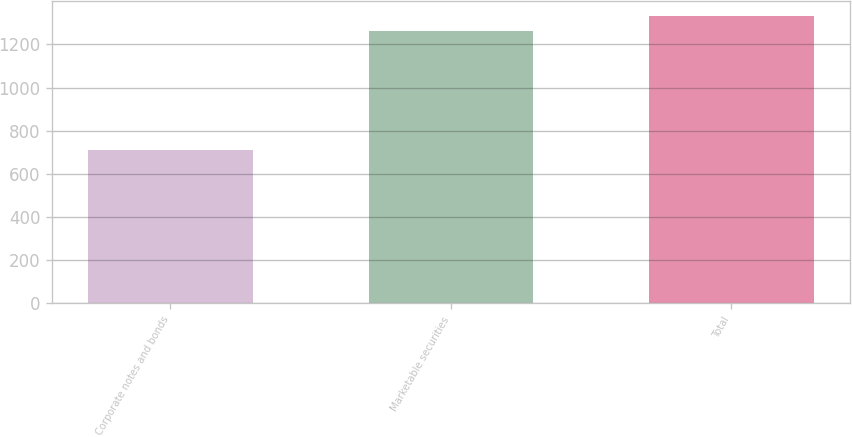Convert chart to OTSL. <chart><loc_0><loc_0><loc_500><loc_500><bar_chart><fcel>Corporate notes and bonds<fcel>Marketable securities<fcel>Total<nl><fcel>711<fcel>1260<fcel>1333<nl></chart> 